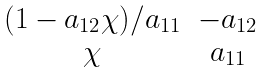Convert formula to latex. <formula><loc_0><loc_0><loc_500><loc_500>\begin{matrix} { ( 1 - a _ { 1 2 } \chi ) / a _ { 1 1 } } & - a _ { 1 2 } \\ \chi & a _ { 1 1 } \\ \end{matrix}</formula> 